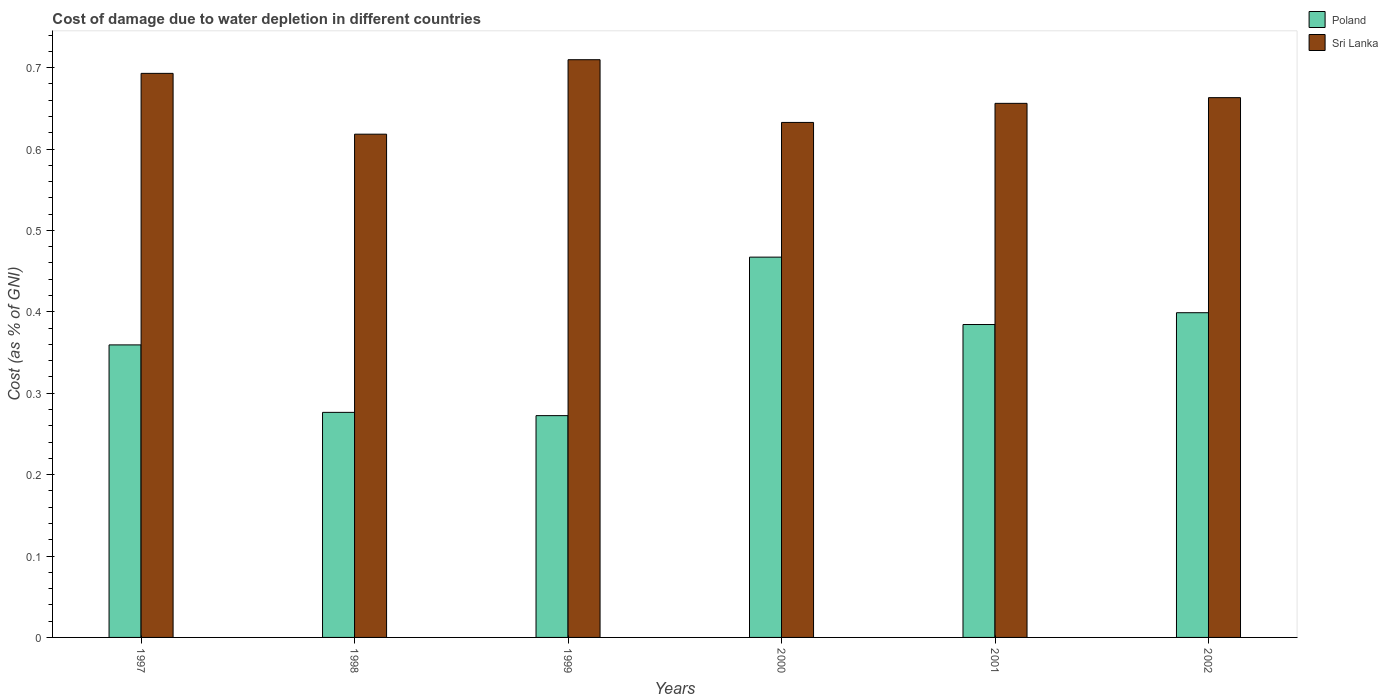How many different coloured bars are there?
Give a very brief answer. 2. Are the number of bars per tick equal to the number of legend labels?
Offer a terse response. Yes. How many bars are there on the 5th tick from the left?
Give a very brief answer. 2. How many bars are there on the 4th tick from the right?
Your response must be concise. 2. What is the label of the 1st group of bars from the left?
Your answer should be very brief. 1997. In how many cases, is the number of bars for a given year not equal to the number of legend labels?
Provide a short and direct response. 0. What is the cost of damage caused due to water depletion in Sri Lanka in 1999?
Give a very brief answer. 0.71. Across all years, what is the maximum cost of damage caused due to water depletion in Poland?
Provide a short and direct response. 0.47. Across all years, what is the minimum cost of damage caused due to water depletion in Sri Lanka?
Make the answer very short. 0.62. In which year was the cost of damage caused due to water depletion in Sri Lanka maximum?
Your response must be concise. 1999. What is the total cost of damage caused due to water depletion in Poland in the graph?
Keep it short and to the point. 2.16. What is the difference between the cost of damage caused due to water depletion in Sri Lanka in 1999 and that in 2000?
Offer a very short reply. 0.08. What is the difference between the cost of damage caused due to water depletion in Poland in 1997 and the cost of damage caused due to water depletion in Sri Lanka in 2001?
Your answer should be compact. -0.3. What is the average cost of damage caused due to water depletion in Sri Lanka per year?
Give a very brief answer. 0.66. In the year 1997, what is the difference between the cost of damage caused due to water depletion in Sri Lanka and cost of damage caused due to water depletion in Poland?
Offer a terse response. 0.33. What is the ratio of the cost of damage caused due to water depletion in Poland in 1998 to that in 2002?
Your response must be concise. 0.69. Is the cost of damage caused due to water depletion in Sri Lanka in 2000 less than that in 2001?
Offer a terse response. Yes. What is the difference between the highest and the second highest cost of damage caused due to water depletion in Poland?
Give a very brief answer. 0.07. What is the difference between the highest and the lowest cost of damage caused due to water depletion in Sri Lanka?
Make the answer very short. 0.09. Is the sum of the cost of damage caused due to water depletion in Sri Lanka in 1998 and 2000 greater than the maximum cost of damage caused due to water depletion in Poland across all years?
Give a very brief answer. Yes. What does the 1st bar from the right in 1999 represents?
Offer a terse response. Sri Lanka. How many bars are there?
Your response must be concise. 12. Does the graph contain any zero values?
Provide a succinct answer. No. What is the title of the graph?
Your response must be concise. Cost of damage due to water depletion in different countries. Does "Chad" appear as one of the legend labels in the graph?
Make the answer very short. No. What is the label or title of the Y-axis?
Provide a succinct answer. Cost (as % of GNI). What is the Cost (as % of GNI) of Poland in 1997?
Your response must be concise. 0.36. What is the Cost (as % of GNI) in Sri Lanka in 1997?
Ensure brevity in your answer.  0.69. What is the Cost (as % of GNI) in Poland in 1998?
Keep it short and to the point. 0.28. What is the Cost (as % of GNI) of Sri Lanka in 1998?
Make the answer very short. 0.62. What is the Cost (as % of GNI) of Poland in 1999?
Your response must be concise. 0.27. What is the Cost (as % of GNI) in Sri Lanka in 1999?
Your response must be concise. 0.71. What is the Cost (as % of GNI) in Poland in 2000?
Offer a terse response. 0.47. What is the Cost (as % of GNI) of Sri Lanka in 2000?
Give a very brief answer. 0.63. What is the Cost (as % of GNI) of Poland in 2001?
Make the answer very short. 0.38. What is the Cost (as % of GNI) in Sri Lanka in 2001?
Your response must be concise. 0.66. What is the Cost (as % of GNI) in Poland in 2002?
Give a very brief answer. 0.4. What is the Cost (as % of GNI) in Sri Lanka in 2002?
Provide a short and direct response. 0.66. Across all years, what is the maximum Cost (as % of GNI) in Poland?
Provide a succinct answer. 0.47. Across all years, what is the maximum Cost (as % of GNI) of Sri Lanka?
Your answer should be compact. 0.71. Across all years, what is the minimum Cost (as % of GNI) of Poland?
Your answer should be compact. 0.27. Across all years, what is the minimum Cost (as % of GNI) in Sri Lanka?
Provide a short and direct response. 0.62. What is the total Cost (as % of GNI) in Poland in the graph?
Your response must be concise. 2.16. What is the total Cost (as % of GNI) of Sri Lanka in the graph?
Offer a very short reply. 3.97. What is the difference between the Cost (as % of GNI) in Poland in 1997 and that in 1998?
Keep it short and to the point. 0.08. What is the difference between the Cost (as % of GNI) in Sri Lanka in 1997 and that in 1998?
Provide a succinct answer. 0.07. What is the difference between the Cost (as % of GNI) in Poland in 1997 and that in 1999?
Your answer should be very brief. 0.09. What is the difference between the Cost (as % of GNI) of Sri Lanka in 1997 and that in 1999?
Ensure brevity in your answer.  -0.02. What is the difference between the Cost (as % of GNI) in Poland in 1997 and that in 2000?
Give a very brief answer. -0.11. What is the difference between the Cost (as % of GNI) in Sri Lanka in 1997 and that in 2000?
Provide a succinct answer. 0.06. What is the difference between the Cost (as % of GNI) of Poland in 1997 and that in 2001?
Ensure brevity in your answer.  -0.03. What is the difference between the Cost (as % of GNI) of Sri Lanka in 1997 and that in 2001?
Make the answer very short. 0.04. What is the difference between the Cost (as % of GNI) of Poland in 1997 and that in 2002?
Give a very brief answer. -0.04. What is the difference between the Cost (as % of GNI) of Sri Lanka in 1997 and that in 2002?
Provide a succinct answer. 0.03. What is the difference between the Cost (as % of GNI) in Poland in 1998 and that in 1999?
Your response must be concise. 0. What is the difference between the Cost (as % of GNI) in Sri Lanka in 1998 and that in 1999?
Your answer should be compact. -0.09. What is the difference between the Cost (as % of GNI) of Poland in 1998 and that in 2000?
Offer a terse response. -0.19. What is the difference between the Cost (as % of GNI) of Sri Lanka in 1998 and that in 2000?
Give a very brief answer. -0.01. What is the difference between the Cost (as % of GNI) of Poland in 1998 and that in 2001?
Make the answer very short. -0.11. What is the difference between the Cost (as % of GNI) of Sri Lanka in 1998 and that in 2001?
Ensure brevity in your answer.  -0.04. What is the difference between the Cost (as % of GNI) of Poland in 1998 and that in 2002?
Offer a terse response. -0.12. What is the difference between the Cost (as % of GNI) in Sri Lanka in 1998 and that in 2002?
Your answer should be very brief. -0.04. What is the difference between the Cost (as % of GNI) in Poland in 1999 and that in 2000?
Ensure brevity in your answer.  -0.19. What is the difference between the Cost (as % of GNI) in Sri Lanka in 1999 and that in 2000?
Provide a short and direct response. 0.08. What is the difference between the Cost (as % of GNI) of Poland in 1999 and that in 2001?
Your response must be concise. -0.11. What is the difference between the Cost (as % of GNI) of Sri Lanka in 1999 and that in 2001?
Give a very brief answer. 0.05. What is the difference between the Cost (as % of GNI) of Poland in 1999 and that in 2002?
Make the answer very short. -0.13. What is the difference between the Cost (as % of GNI) in Sri Lanka in 1999 and that in 2002?
Your answer should be compact. 0.05. What is the difference between the Cost (as % of GNI) in Poland in 2000 and that in 2001?
Your response must be concise. 0.08. What is the difference between the Cost (as % of GNI) of Sri Lanka in 2000 and that in 2001?
Offer a terse response. -0.02. What is the difference between the Cost (as % of GNI) of Poland in 2000 and that in 2002?
Your answer should be very brief. 0.07. What is the difference between the Cost (as % of GNI) of Sri Lanka in 2000 and that in 2002?
Give a very brief answer. -0.03. What is the difference between the Cost (as % of GNI) in Poland in 2001 and that in 2002?
Your answer should be compact. -0.01. What is the difference between the Cost (as % of GNI) in Sri Lanka in 2001 and that in 2002?
Provide a short and direct response. -0.01. What is the difference between the Cost (as % of GNI) in Poland in 1997 and the Cost (as % of GNI) in Sri Lanka in 1998?
Provide a succinct answer. -0.26. What is the difference between the Cost (as % of GNI) in Poland in 1997 and the Cost (as % of GNI) in Sri Lanka in 1999?
Make the answer very short. -0.35. What is the difference between the Cost (as % of GNI) of Poland in 1997 and the Cost (as % of GNI) of Sri Lanka in 2000?
Your response must be concise. -0.27. What is the difference between the Cost (as % of GNI) in Poland in 1997 and the Cost (as % of GNI) in Sri Lanka in 2001?
Keep it short and to the point. -0.3. What is the difference between the Cost (as % of GNI) of Poland in 1997 and the Cost (as % of GNI) of Sri Lanka in 2002?
Your response must be concise. -0.3. What is the difference between the Cost (as % of GNI) in Poland in 1998 and the Cost (as % of GNI) in Sri Lanka in 1999?
Give a very brief answer. -0.43. What is the difference between the Cost (as % of GNI) of Poland in 1998 and the Cost (as % of GNI) of Sri Lanka in 2000?
Provide a succinct answer. -0.36. What is the difference between the Cost (as % of GNI) of Poland in 1998 and the Cost (as % of GNI) of Sri Lanka in 2001?
Your response must be concise. -0.38. What is the difference between the Cost (as % of GNI) of Poland in 1998 and the Cost (as % of GNI) of Sri Lanka in 2002?
Offer a very short reply. -0.39. What is the difference between the Cost (as % of GNI) of Poland in 1999 and the Cost (as % of GNI) of Sri Lanka in 2000?
Give a very brief answer. -0.36. What is the difference between the Cost (as % of GNI) in Poland in 1999 and the Cost (as % of GNI) in Sri Lanka in 2001?
Your answer should be very brief. -0.38. What is the difference between the Cost (as % of GNI) in Poland in 1999 and the Cost (as % of GNI) in Sri Lanka in 2002?
Your response must be concise. -0.39. What is the difference between the Cost (as % of GNI) in Poland in 2000 and the Cost (as % of GNI) in Sri Lanka in 2001?
Ensure brevity in your answer.  -0.19. What is the difference between the Cost (as % of GNI) in Poland in 2000 and the Cost (as % of GNI) in Sri Lanka in 2002?
Your response must be concise. -0.2. What is the difference between the Cost (as % of GNI) in Poland in 2001 and the Cost (as % of GNI) in Sri Lanka in 2002?
Keep it short and to the point. -0.28. What is the average Cost (as % of GNI) of Poland per year?
Make the answer very short. 0.36. What is the average Cost (as % of GNI) of Sri Lanka per year?
Your response must be concise. 0.66. In the year 1997, what is the difference between the Cost (as % of GNI) in Poland and Cost (as % of GNI) in Sri Lanka?
Provide a succinct answer. -0.33. In the year 1998, what is the difference between the Cost (as % of GNI) in Poland and Cost (as % of GNI) in Sri Lanka?
Keep it short and to the point. -0.34. In the year 1999, what is the difference between the Cost (as % of GNI) in Poland and Cost (as % of GNI) in Sri Lanka?
Provide a short and direct response. -0.44. In the year 2000, what is the difference between the Cost (as % of GNI) of Poland and Cost (as % of GNI) of Sri Lanka?
Your response must be concise. -0.17. In the year 2001, what is the difference between the Cost (as % of GNI) in Poland and Cost (as % of GNI) in Sri Lanka?
Make the answer very short. -0.27. In the year 2002, what is the difference between the Cost (as % of GNI) of Poland and Cost (as % of GNI) of Sri Lanka?
Make the answer very short. -0.26. What is the ratio of the Cost (as % of GNI) of Poland in 1997 to that in 1998?
Offer a very short reply. 1.3. What is the ratio of the Cost (as % of GNI) in Sri Lanka in 1997 to that in 1998?
Provide a short and direct response. 1.12. What is the ratio of the Cost (as % of GNI) of Poland in 1997 to that in 1999?
Give a very brief answer. 1.32. What is the ratio of the Cost (as % of GNI) of Sri Lanka in 1997 to that in 1999?
Your response must be concise. 0.98. What is the ratio of the Cost (as % of GNI) of Poland in 1997 to that in 2000?
Your response must be concise. 0.77. What is the ratio of the Cost (as % of GNI) of Sri Lanka in 1997 to that in 2000?
Your answer should be compact. 1.1. What is the ratio of the Cost (as % of GNI) of Poland in 1997 to that in 2001?
Ensure brevity in your answer.  0.93. What is the ratio of the Cost (as % of GNI) of Sri Lanka in 1997 to that in 2001?
Your answer should be compact. 1.06. What is the ratio of the Cost (as % of GNI) of Poland in 1997 to that in 2002?
Ensure brevity in your answer.  0.9. What is the ratio of the Cost (as % of GNI) of Sri Lanka in 1997 to that in 2002?
Keep it short and to the point. 1.04. What is the ratio of the Cost (as % of GNI) of Poland in 1998 to that in 1999?
Offer a very short reply. 1.01. What is the ratio of the Cost (as % of GNI) in Sri Lanka in 1998 to that in 1999?
Give a very brief answer. 0.87. What is the ratio of the Cost (as % of GNI) of Poland in 1998 to that in 2000?
Your response must be concise. 0.59. What is the ratio of the Cost (as % of GNI) of Sri Lanka in 1998 to that in 2000?
Offer a terse response. 0.98. What is the ratio of the Cost (as % of GNI) of Poland in 1998 to that in 2001?
Your answer should be very brief. 0.72. What is the ratio of the Cost (as % of GNI) of Sri Lanka in 1998 to that in 2001?
Give a very brief answer. 0.94. What is the ratio of the Cost (as % of GNI) in Poland in 1998 to that in 2002?
Offer a very short reply. 0.69. What is the ratio of the Cost (as % of GNI) of Sri Lanka in 1998 to that in 2002?
Provide a succinct answer. 0.93. What is the ratio of the Cost (as % of GNI) of Poland in 1999 to that in 2000?
Your answer should be compact. 0.58. What is the ratio of the Cost (as % of GNI) of Sri Lanka in 1999 to that in 2000?
Keep it short and to the point. 1.12. What is the ratio of the Cost (as % of GNI) of Poland in 1999 to that in 2001?
Your answer should be compact. 0.71. What is the ratio of the Cost (as % of GNI) of Sri Lanka in 1999 to that in 2001?
Offer a very short reply. 1.08. What is the ratio of the Cost (as % of GNI) in Poland in 1999 to that in 2002?
Keep it short and to the point. 0.68. What is the ratio of the Cost (as % of GNI) in Sri Lanka in 1999 to that in 2002?
Make the answer very short. 1.07. What is the ratio of the Cost (as % of GNI) in Poland in 2000 to that in 2001?
Give a very brief answer. 1.22. What is the ratio of the Cost (as % of GNI) of Sri Lanka in 2000 to that in 2001?
Your answer should be compact. 0.96. What is the ratio of the Cost (as % of GNI) in Poland in 2000 to that in 2002?
Your answer should be very brief. 1.17. What is the ratio of the Cost (as % of GNI) of Sri Lanka in 2000 to that in 2002?
Provide a short and direct response. 0.95. What is the ratio of the Cost (as % of GNI) of Poland in 2001 to that in 2002?
Keep it short and to the point. 0.96. What is the ratio of the Cost (as % of GNI) in Sri Lanka in 2001 to that in 2002?
Your answer should be very brief. 0.99. What is the difference between the highest and the second highest Cost (as % of GNI) of Poland?
Provide a succinct answer. 0.07. What is the difference between the highest and the second highest Cost (as % of GNI) in Sri Lanka?
Provide a short and direct response. 0.02. What is the difference between the highest and the lowest Cost (as % of GNI) of Poland?
Offer a terse response. 0.19. What is the difference between the highest and the lowest Cost (as % of GNI) in Sri Lanka?
Offer a terse response. 0.09. 